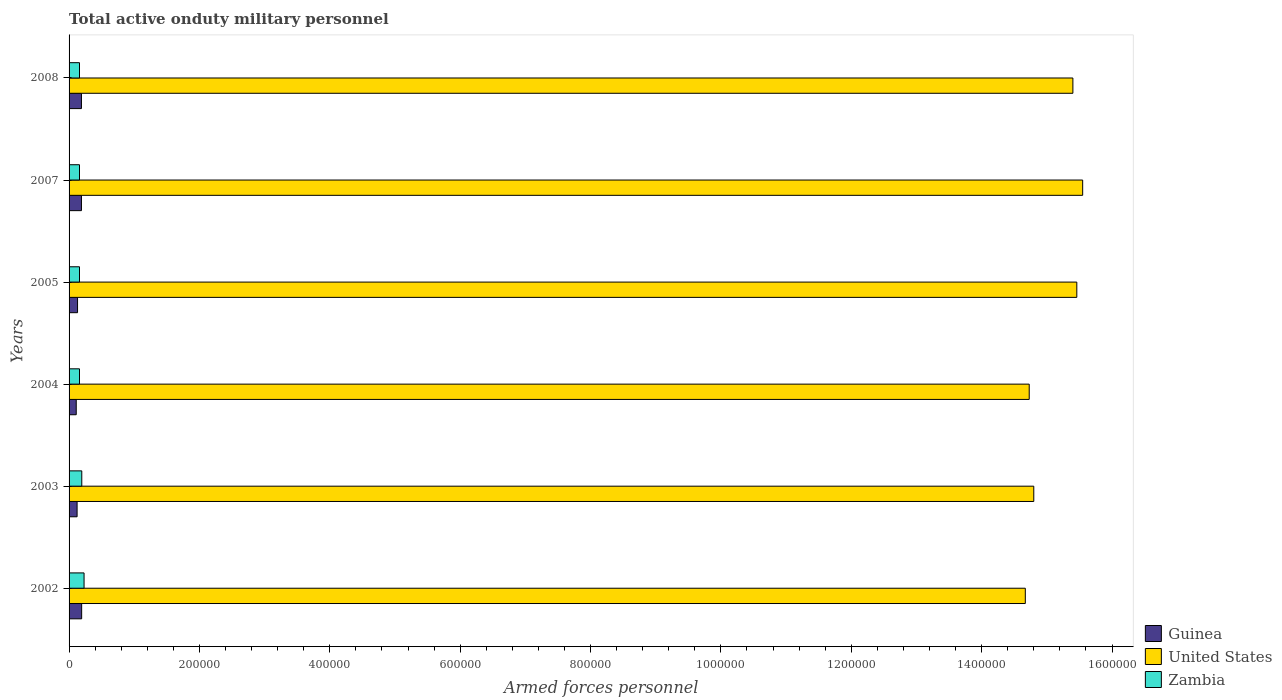Are the number of bars on each tick of the Y-axis equal?
Keep it short and to the point. Yes. How many bars are there on the 3rd tick from the top?
Your response must be concise. 3. How many bars are there on the 5th tick from the bottom?
Ensure brevity in your answer.  3. What is the number of armed forces personnel in Guinea in 2004?
Your answer should be compact. 1.10e+04. Across all years, what is the maximum number of armed forces personnel in Guinea?
Give a very brief answer. 1.93e+04. Across all years, what is the minimum number of armed forces personnel in Zambia?
Give a very brief answer. 1.60e+04. What is the total number of armed forces personnel in United States in the graph?
Ensure brevity in your answer.  9.06e+06. What is the difference between the number of armed forces personnel in Zambia in 2002 and that in 2004?
Provide a succinct answer. 7000. What is the difference between the number of armed forces personnel in Guinea in 2007 and the number of armed forces personnel in Zambia in 2003?
Give a very brief answer. -500. What is the average number of armed forces personnel in United States per year?
Make the answer very short. 1.51e+06. In the year 2008, what is the difference between the number of armed forces personnel in United States and number of armed forces personnel in Guinea?
Your response must be concise. 1.52e+06. In how many years, is the number of armed forces personnel in Zambia greater than 800000 ?
Keep it short and to the point. 0. What is the ratio of the number of armed forces personnel in Zambia in 2005 to that in 2007?
Your response must be concise. 1. Is the number of armed forces personnel in Guinea in 2002 less than that in 2003?
Your answer should be compact. No. What is the difference between the highest and the second highest number of armed forces personnel in Guinea?
Your answer should be very brief. 300. What is the difference between the highest and the lowest number of armed forces personnel in Zambia?
Provide a short and direct response. 7000. In how many years, is the number of armed forces personnel in Guinea greater than the average number of armed forces personnel in Guinea taken over all years?
Offer a terse response. 3. What does the 2nd bar from the top in 2003 represents?
Ensure brevity in your answer.  United States. What does the 3rd bar from the bottom in 2008 represents?
Your answer should be very brief. Zambia. How many years are there in the graph?
Your answer should be very brief. 6. Does the graph contain any zero values?
Keep it short and to the point. No. Where does the legend appear in the graph?
Ensure brevity in your answer.  Bottom right. How are the legend labels stacked?
Give a very brief answer. Vertical. What is the title of the graph?
Provide a succinct answer. Total active onduty military personnel. Does "Trinidad and Tobago" appear as one of the legend labels in the graph?
Provide a short and direct response. No. What is the label or title of the X-axis?
Make the answer very short. Armed forces personnel. What is the Armed forces personnel in Guinea in 2002?
Your response must be concise. 1.93e+04. What is the Armed forces personnel in United States in 2002?
Your answer should be very brief. 1.47e+06. What is the Armed forces personnel of Zambia in 2002?
Provide a succinct answer. 2.30e+04. What is the Armed forces personnel in Guinea in 2003?
Give a very brief answer. 1.23e+04. What is the Armed forces personnel in United States in 2003?
Make the answer very short. 1.48e+06. What is the Armed forces personnel of Zambia in 2003?
Make the answer very short. 1.95e+04. What is the Armed forces personnel in Guinea in 2004?
Offer a terse response. 1.10e+04. What is the Armed forces personnel in United States in 2004?
Keep it short and to the point. 1.47e+06. What is the Armed forces personnel in Zambia in 2004?
Give a very brief answer. 1.60e+04. What is the Armed forces personnel of Guinea in 2005?
Provide a short and direct response. 1.30e+04. What is the Armed forces personnel of United States in 2005?
Make the answer very short. 1.55e+06. What is the Armed forces personnel in Zambia in 2005?
Make the answer very short. 1.60e+04. What is the Armed forces personnel of Guinea in 2007?
Provide a succinct answer. 1.90e+04. What is the Armed forces personnel in United States in 2007?
Ensure brevity in your answer.  1.56e+06. What is the Armed forces personnel of Zambia in 2007?
Provide a succinct answer. 1.60e+04. What is the Armed forces personnel in Guinea in 2008?
Provide a succinct answer. 1.90e+04. What is the Armed forces personnel of United States in 2008?
Your response must be concise. 1.54e+06. What is the Armed forces personnel in Zambia in 2008?
Make the answer very short. 1.60e+04. Across all years, what is the maximum Armed forces personnel in Guinea?
Provide a succinct answer. 1.93e+04. Across all years, what is the maximum Armed forces personnel in United States?
Your answer should be compact. 1.56e+06. Across all years, what is the maximum Armed forces personnel of Zambia?
Your answer should be compact. 2.30e+04. Across all years, what is the minimum Armed forces personnel of Guinea?
Ensure brevity in your answer.  1.10e+04. Across all years, what is the minimum Armed forces personnel of United States?
Make the answer very short. 1.47e+06. Across all years, what is the minimum Armed forces personnel of Zambia?
Your response must be concise. 1.60e+04. What is the total Armed forces personnel in Guinea in the graph?
Provide a succinct answer. 9.36e+04. What is the total Armed forces personnel of United States in the graph?
Ensure brevity in your answer.  9.06e+06. What is the total Armed forces personnel in Zambia in the graph?
Keep it short and to the point. 1.06e+05. What is the difference between the Armed forces personnel in Guinea in 2002 and that in 2003?
Ensure brevity in your answer.  7000. What is the difference between the Armed forces personnel in United States in 2002 and that in 2003?
Provide a short and direct response. -1.30e+04. What is the difference between the Armed forces personnel in Zambia in 2002 and that in 2003?
Keep it short and to the point. 3500. What is the difference between the Armed forces personnel of Guinea in 2002 and that in 2004?
Make the answer very short. 8300. What is the difference between the Armed forces personnel of United States in 2002 and that in 2004?
Offer a terse response. -6000. What is the difference between the Armed forces personnel of Zambia in 2002 and that in 2004?
Give a very brief answer. 7000. What is the difference between the Armed forces personnel of Guinea in 2002 and that in 2005?
Offer a very short reply. 6300. What is the difference between the Armed forces personnel in United States in 2002 and that in 2005?
Your response must be concise. -7.90e+04. What is the difference between the Armed forces personnel in Zambia in 2002 and that in 2005?
Offer a terse response. 7000. What is the difference between the Armed forces personnel in Guinea in 2002 and that in 2007?
Keep it short and to the point. 300. What is the difference between the Armed forces personnel in United States in 2002 and that in 2007?
Offer a terse response. -8.80e+04. What is the difference between the Armed forces personnel in Zambia in 2002 and that in 2007?
Provide a short and direct response. 7000. What is the difference between the Armed forces personnel in Guinea in 2002 and that in 2008?
Your answer should be compact. 300. What is the difference between the Armed forces personnel in United States in 2002 and that in 2008?
Make the answer very short. -7.30e+04. What is the difference between the Armed forces personnel of Zambia in 2002 and that in 2008?
Ensure brevity in your answer.  7000. What is the difference between the Armed forces personnel in Guinea in 2003 and that in 2004?
Ensure brevity in your answer.  1300. What is the difference between the Armed forces personnel in United States in 2003 and that in 2004?
Your answer should be compact. 7000. What is the difference between the Armed forces personnel of Zambia in 2003 and that in 2004?
Make the answer very short. 3500. What is the difference between the Armed forces personnel in Guinea in 2003 and that in 2005?
Your answer should be compact. -700. What is the difference between the Armed forces personnel of United States in 2003 and that in 2005?
Provide a succinct answer. -6.60e+04. What is the difference between the Armed forces personnel in Zambia in 2003 and that in 2005?
Give a very brief answer. 3500. What is the difference between the Armed forces personnel in Guinea in 2003 and that in 2007?
Offer a very short reply. -6700. What is the difference between the Armed forces personnel in United States in 2003 and that in 2007?
Your answer should be very brief. -7.50e+04. What is the difference between the Armed forces personnel in Zambia in 2003 and that in 2007?
Your answer should be very brief. 3500. What is the difference between the Armed forces personnel of Guinea in 2003 and that in 2008?
Offer a terse response. -6700. What is the difference between the Armed forces personnel of Zambia in 2003 and that in 2008?
Make the answer very short. 3500. What is the difference between the Armed forces personnel of Guinea in 2004 and that in 2005?
Give a very brief answer. -2000. What is the difference between the Armed forces personnel of United States in 2004 and that in 2005?
Give a very brief answer. -7.30e+04. What is the difference between the Armed forces personnel of Zambia in 2004 and that in 2005?
Make the answer very short. 0. What is the difference between the Armed forces personnel in Guinea in 2004 and that in 2007?
Your answer should be compact. -8000. What is the difference between the Armed forces personnel in United States in 2004 and that in 2007?
Provide a succinct answer. -8.20e+04. What is the difference between the Armed forces personnel of Guinea in 2004 and that in 2008?
Make the answer very short. -8000. What is the difference between the Armed forces personnel of United States in 2004 and that in 2008?
Provide a succinct answer. -6.70e+04. What is the difference between the Armed forces personnel in Zambia in 2004 and that in 2008?
Provide a succinct answer. 0. What is the difference between the Armed forces personnel of Guinea in 2005 and that in 2007?
Give a very brief answer. -6000. What is the difference between the Armed forces personnel of United States in 2005 and that in 2007?
Your response must be concise. -9000. What is the difference between the Armed forces personnel in Zambia in 2005 and that in 2007?
Provide a short and direct response. 0. What is the difference between the Armed forces personnel of Guinea in 2005 and that in 2008?
Ensure brevity in your answer.  -6000. What is the difference between the Armed forces personnel in United States in 2005 and that in 2008?
Make the answer very short. 6000. What is the difference between the Armed forces personnel of United States in 2007 and that in 2008?
Provide a succinct answer. 1.50e+04. What is the difference between the Armed forces personnel in Zambia in 2007 and that in 2008?
Offer a very short reply. 0. What is the difference between the Armed forces personnel in Guinea in 2002 and the Armed forces personnel in United States in 2003?
Provide a short and direct response. -1.46e+06. What is the difference between the Armed forces personnel of Guinea in 2002 and the Armed forces personnel of Zambia in 2003?
Offer a terse response. -200. What is the difference between the Armed forces personnel in United States in 2002 and the Armed forces personnel in Zambia in 2003?
Ensure brevity in your answer.  1.45e+06. What is the difference between the Armed forces personnel of Guinea in 2002 and the Armed forces personnel of United States in 2004?
Keep it short and to the point. -1.45e+06. What is the difference between the Armed forces personnel in Guinea in 2002 and the Armed forces personnel in Zambia in 2004?
Your answer should be very brief. 3300. What is the difference between the Armed forces personnel in United States in 2002 and the Armed forces personnel in Zambia in 2004?
Make the answer very short. 1.45e+06. What is the difference between the Armed forces personnel in Guinea in 2002 and the Armed forces personnel in United States in 2005?
Your answer should be very brief. -1.53e+06. What is the difference between the Armed forces personnel of Guinea in 2002 and the Armed forces personnel of Zambia in 2005?
Your answer should be very brief. 3300. What is the difference between the Armed forces personnel of United States in 2002 and the Armed forces personnel of Zambia in 2005?
Offer a very short reply. 1.45e+06. What is the difference between the Armed forces personnel of Guinea in 2002 and the Armed forces personnel of United States in 2007?
Give a very brief answer. -1.54e+06. What is the difference between the Armed forces personnel in Guinea in 2002 and the Armed forces personnel in Zambia in 2007?
Offer a terse response. 3300. What is the difference between the Armed forces personnel in United States in 2002 and the Armed forces personnel in Zambia in 2007?
Keep it short and to the point. 1.45e+06. What is the difference between the Armed forces personnel in Guinea in 2002 and the Armed forces personnel in United States in 2008?
Keep it short and to the point. -1.52e+06. What is the difference between the Armed forces personnel in Guinea in 2002 and the Armed forces personnel in Zambia in 2008?
Your response must be concise. 3300. What is the difference between the Armed forces personnel in United States in 2002 and the Armed forces personnel in Zambia in 2008?
Give a very brief answer. 1.45e+06. What is the difference between the Armed forces personnel of Guinea in 2003 and the Armed forces personnel of United States in 2004?
Provide a short and direct response. -1.46e+06. What is the difference between the Armed forces personnel in Guinea in 2003 and the Armed forces personnel in Zambia in 2004?
Offer a terse response. -3700. What is the difference between the Armed forces personnel of United States in 2003 and the Armed forces personnel of Zambia in 2004?
Offer a very short reply. 1.46e+06. What is the difference between the Armed forces personnel in Guinea in 2003 and the Armed forces personnel in United States in 2005?
Provide a short and direct response. -1.53e+06. What is the difference between the Armed forces personnel in Guinea in 2003 and the Armed forces personnel in Zambia in 2005?
Make the answer very short. -3700. What is the difference between the Armed forces personnel of United States in 2003 and the Armed forces personnel of Zambia in 2005?
Your response must be concise. 1.46e+06. What is the difference between the Armed forces personnel in Guinea in 2003 and the Armed forces personnel in United States in 2007?
Provide a succinct answer. -1.54e+06. What is the difference between the Armed forces personnel of Guinea in 2003 and the Armed forces personnel of Zambia in 2007?
Your response must be concise. -3700. What is the difference between the Armed forces personnel of United States in 2003 and the Armed forces personnel of Zambia in 2007?
Offer a very short reply. 1.46e+06. What is the difference between the Armed forces personnel of Guinea in 2003 and the Armed forces personnel of United States in 2008?
Provide a succinct answer. -1.53e+06. What is the difference between the Armed forces personnel in Guinea in 2003 and the Armed forces personnel in Zambia in 2008?
Make the answer very short. -3700. What is the difference between the Armed forces personnel in United States in 2003 and the Armed forces personnel in Zambia in 2008?
Your answer should be compact. 1.46e+06. What is the difference between the Armed forces personnel of Guinea in 2004 and the Armed forces personnel of United States in 2005?
Keep it short and to the point. -1.54e+06. What is the difference between the Armed forces personnel in Guinea in 2004 and the Armed forces personnel in Zambia in 2005?
Provide a succinct answer. -5000. What is the difference between the Armed forces personnel in United States in 2004 and the Armed forces personnel in Zambia in 2005?
Your answer should be very brief. 1.46e+06. What is the difference between the Armed forces personnel in Guinea in 2004 and the Armed forces personnel in United States in 2007?
Your answer should be very brief. -1.54e+06. What is the difference between the Armed forces personnel in Guinea in 2004 and the Armed forces personnel in Zambia in 2007?
Your response must be concise. -5000. What is the difference between the Armed forces personnel of United States in 2004 and the Armed forces personnel of Zambia in 2007?
Your answer should be very brief. 1.46e+06. What is the difference between the Armed forces personnel in Guinea in 2004 and the Armed forces personnel in United States in 2008?
Ensure brevity in your answer.  -1.53e+06. What is the difference between the Armed forces personnel in Guinea in 2004 and the Armed forces personnel in Zambia in 2008?
Provide a short and direct response. -5000. What is the difference between the Armed forces personnel of United States in 2004 and the Armed forces personnel of Zambia in 2008?
Keep it short and to the point. 1.46e+06. What is the difference between the Armed forces personnel of Guinea in 2005 and the Armed forces personnel of United States in 2007?
Give a very brief answer. -1.54e+06. What is the difference between the Armed forces personnel of Guinea in 2005 and the Armed forces personnel of Zambia in 2007?
Your answer should be very brief. -3000. What is the difference between the Armed forces personnel in United States in 2005 and the Armed forces personnel in Zambia in 2007?
Your answer should be very brief. 1.53e+06. What is the difference between the Armed forces personnel in Guinea in 2005 and the Armed forces personnel in United States in 2008?
Your response must be concise. -1.53e+06. What is the difference between the Armed forces personnel in Guinea in 2005 and the Armed forces personnel in Zambia in 2008?
Provide a short and direct response. -3000. What is the difference between the Armed forces personnel in United States in 2005 and the Armed forces personnel in Zambia in 2008?
Give a very brief answer. 1.53e+06. What is the difference between the Armed forces personnel in Guinea in 2007 and the Armed forces personnel in United States in 2008?
Provide a short and direct response. -1.52e+06. What is the difference between the Armed forces personnel in Guinea in 2007 and the Armed forces personnel in Zambia in 2008?
Make the answer very short. 3000. What is the difference between the Armed forces personnel of United States in 2007 and the Armed forces personnel of Zambia in 2008?
Keep it short and to the point. 1.54e+06. What is the average Armed forces personnel in Guinea per year?
Offer a terse response. 1.56e+04. What is the average Armed forces personnel of United States per year?
Keep it short and to the point. 1.51e+06. What is the average Armed forces personnel of Zambia per year?
Offer a terse response. 1.78e+04. In the year 2002, what is the difference between the Armed forces personnel in Guinea and Armed forces personnel in United States?
Make the answer very short. -1.45e+06. In the year 2002, what is the difference between the Armed forces personnel in Guinea and Armed forces personnel in Zambia?
Provide a succinct answer. -3700. In the year 2002, what is the difference between the Armed forces personnel of United States and Armed forces personnel of Zambia?
Provide a short and direct response. 1.44e+06. In the year 2003, what is the difference between the Armed forces personnel in Guinea and Armed forces personnel in United States?
Provide a succinct answer. -1.47e+06. In the year 2003, what is the difference between the Armed forces personnel in Guinea and Armed forces personnel in Zambia?
Give a very brief answer. -7200. In the year 2003, what is the difference between the Armed forces personnel in United States and Armed forces personnel in Zambia?
Provide a short and direct response. 1.46e+06. In the year 2004, what is the difference between the Armed forces personnel in Guinea and Armed forces personnel in United States?
Your answer should be compact. -1.46e+06. In the year 2004, what is the difference between the Armed forces personnel in Guinea and Armed forces personnel in Zambia?
Make the answer very short. -5000. In the year 2004, what is the difference between the Armed forces personnel of United States and Armed forces personnel of Zambia?
Offer a very short reply. 1.46e+06. In the year 2005, what is the difference between the Armed forces personnel in Guinea and Armed forces personnel in United States?
Offer a very short reply. -1.53e+06. In the year 2005, what is the difference between the Armed forces personnel in Guinea and Armed forces personnel in Zambia?
Offer a terse response. -3000. In the year 2005, what is the difference between the Armed forces personnel in United States and Armed forces personnel in Zambia?
Your answer should be compact. 1.53e+06. In the year 2007, what is the difference between the Armed forces personnel of Guinea and Armed forces personnel of United States?
Your answer should be very brief. -1.54e+06. In the year 2007, what is the difference between the Armed forces personnel in Guinea and Armed forces personnel in Zambia?
Your answer should be compact. 3000. In the year 2007, what is the difference between the Armed forces personnel of United States and Armed forces personnel of Zambia?
Offer a very short reply. 1.54e+06. In the year 2008, what is the difference between the Armed forces personnel in Guinea and Armed forces personnel in United States?
Provide a succinct answer. -1.52e+06. In the year 2008, what is the difference between the Armed forces personnel in Guinea and Armed forces personnel in Zambia?
Your response must be concise. 3000. In the year 2008, what is the difference between the Armed forces personnel in United States and Armed forces personnel in Zambia?
Provide a short and direct response. 1.52e+06. What is the ratio of the Armed forces personnel of Guinea in 2002 to that in 2003?
Your answer should be very brief. 1.57. What is the ratio of the Armed forces personnel of United States in 2002 to that in 2003?
Your answer should be compact. 0.99. What is the ratio of the Armed forces personnel in Zambia in 2002 to that in 2003?
Give a very brief answer. 1.18. What is the ratio of the Armed forces personnel in Guinea in 2002 to that in 2004?
Your response must be concise. 1.75. What is the ratio of the Armed forces personnel of United States in 2002 to that in 2004?
Provide a short and direct response. 1. What is the ratio of the Armed forces personnel in Zambia in 2002 to that in 2004?
Your answer should be compact. 1.44. What is the ratio of the Armed forces personnel in Guinea in 2002 to that in 2005?
Your response must be concise. 1.48. What is the ratio of the Armed forces personnel in United States in 2002 to that in 2005?
Your answer should be compact. 0.95. What is the ratio of the Armed forces personnel of Zambia in 2002 to that in 2005?
Provide a succinct answer. 1.44. What is the ratio of the Armed forces personnel in Guinea in 2002 to that in 2007?
Keep it short and to the point. 1.02. What is the ratio of the Armed forces personnel in United States in 2002 to that in 2007?
Ensure brevity in your answer.  0.94. What is the ratio of the Armed forces personnel of Zambia in 2002 to that in 2007?
Give a very brief answer. 1.44. What is the ratio of the Armed forces personnel in Guinea in 2002 to that in 2008?
Your answer should be compact. 1.02. What is the ratio of the Armed forces personnel of United States in 2002 to that in 2008?
Your answer should be very brief. 0.95. What is the ratio of the Armed forces personnel of Zambia in 2002 to that in 2008?
Provide a succinct answer. 1.44. What is the ratio of the Armed forces personnel in Guinea in 2003 to that in 2004?
Your response must be concise. 1.12. What is the ratio of the Armed forces personnel of United States in 2003 to that in 2004?
Your response must be concise. 1. What is the ratio of the Armed forces personnel of Zambia in 2003 to that in 2004?
Make the answer very short. 1.22. What is the ratio of the Armed forces personnel in Guinea in 2003 to that in 2005?
Keep it short and to the point. 0.95. What is the ratio of the Armed forces personnel in United States in 2003 to that in 2005?
Ensure brevity in your answer.  0.96. What is the ratio of the Armed forces personnel in Zambia in 2003 to that in 2005?
Offer a very short reply. 1.22. What is the ratio of the Armed forces personnel in Guinea in 2003 to that in 2007?
Your answer should be compact. 0.65. What is the ratio of the Armed forces personnel of United States in 2003 to that in 2007?
Keep it short and to the point. 0.95. What is the ratio of the Armed forces personnel in Zambia in 2003 to that in 2007?
Provide a short and direct response. 1.22. What is the ratio of the Armed forces personnel of Guinea in 2003 to that in 2008?
Make the answer very short. 0.65. What is the ratio of the Armed forces personnel in United States in 2003 to that in 2008?
Keep it short and to the point. 0.96. What is the ratio of the Armed forces personnel of Zambia in 2003 to that in 2008?
Your response must be concise. 1.22. What is the ratio of the Armed forces personnel in Guinea in 2004 to that in 2005?
Offer a terse response. 0.85. What is the ratio of the Armed forces personnel in United States in 2004 to that in 2005?
Give a very brief answer. 0.95. What is the ratio of the Armed forces personnel of Zambia in 2004 to that in 2005?
Offer a terse response. 1. What is the ratio of the Armed forces personnel of Guinea in 2004 to that in 2007?
Ensure brevity in your answer.  0.58. What is the ratio of the Armed forces personnel in United States in 2004 to that in 2007?
Provide a succinct answer. 0.95. What is the ratio of the Armed forces personnel of Guinea in 2004 to that in 2008?
Provide a succinct answer. 0.58. What is the ratio of the Armed forces personnel of United States in 2004 to that in 2008?
Provide a short and direct response. 0.96. What is the ratio of the Armed forces personnel in Zambia in 2004 to that in 2008?
Give a very brief answer. 1. What is the ratio of the Armed forces personnel of Guinea in 2005 to that in 2007?
Ensure brevity in your answer.  0.68. What is the ratio of the Armed forces personnel in Zambia in 2005 to that in 2007?
Give a very brief answer. 1. What is the ratio of the Armed forces personnel of Guinea in 2005 to that in 2008?
Offer a terse response. 0.68. What is the ratio of the Armed forces personnel in United States in 2005 to that in 2008?
Make the answer very short. 1. What is the ratio of the Armed forces personnel of Zambia in 2005 to that in 2008?
Give a very brief answer. 1. What is the ratio of the Armed forces personnel of Guinea in 2007 to that in 2008?
Provide a succinct answer. 1. What is the ratio of the Armed forces personnel in United States in 2007 to that in 2008?
Provide a short and direct response. 1.01. What is the ratio of the Armed forces personnel in Zambia in 2007 to that in 2008?
Make the answer very short. 1. What is the difference between the highest and the second highest Armed forces personnel of Guinea?
Make the answer very short. 300. What is the difference between the highest and the second highest Armed forces personnel of United States?
Your response must be concise. 9000. What is the difference between the highest and the second highest Armed forces personnel of Zambia?
Provide a short and direct response. 3500. What is the difference between the highest and the lowest Armed forces personnel in Guinea?
Keep it short and to the point. 8300. What is the difference between the highest and the lowest Armed forces personnel in United States?
Provide a succinct answer. 8.80e+04. What is the difference between the highest and the lowest Armed forces personnel of Zambia?
Provide a succinct answer. 7000. 